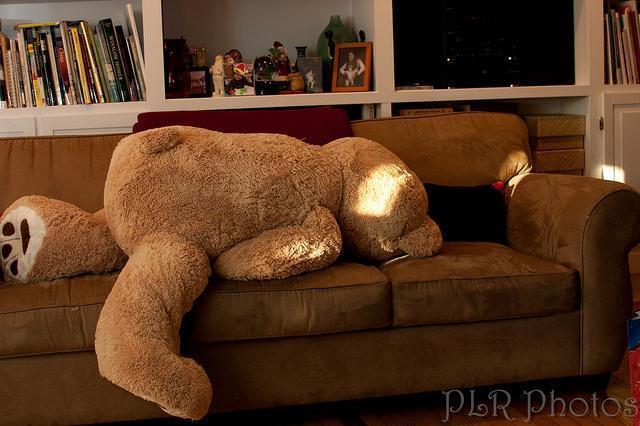Verify the accuracy of this image caption: "The teddy bear is facing the couch.".
Answer yes or no. Yes. 